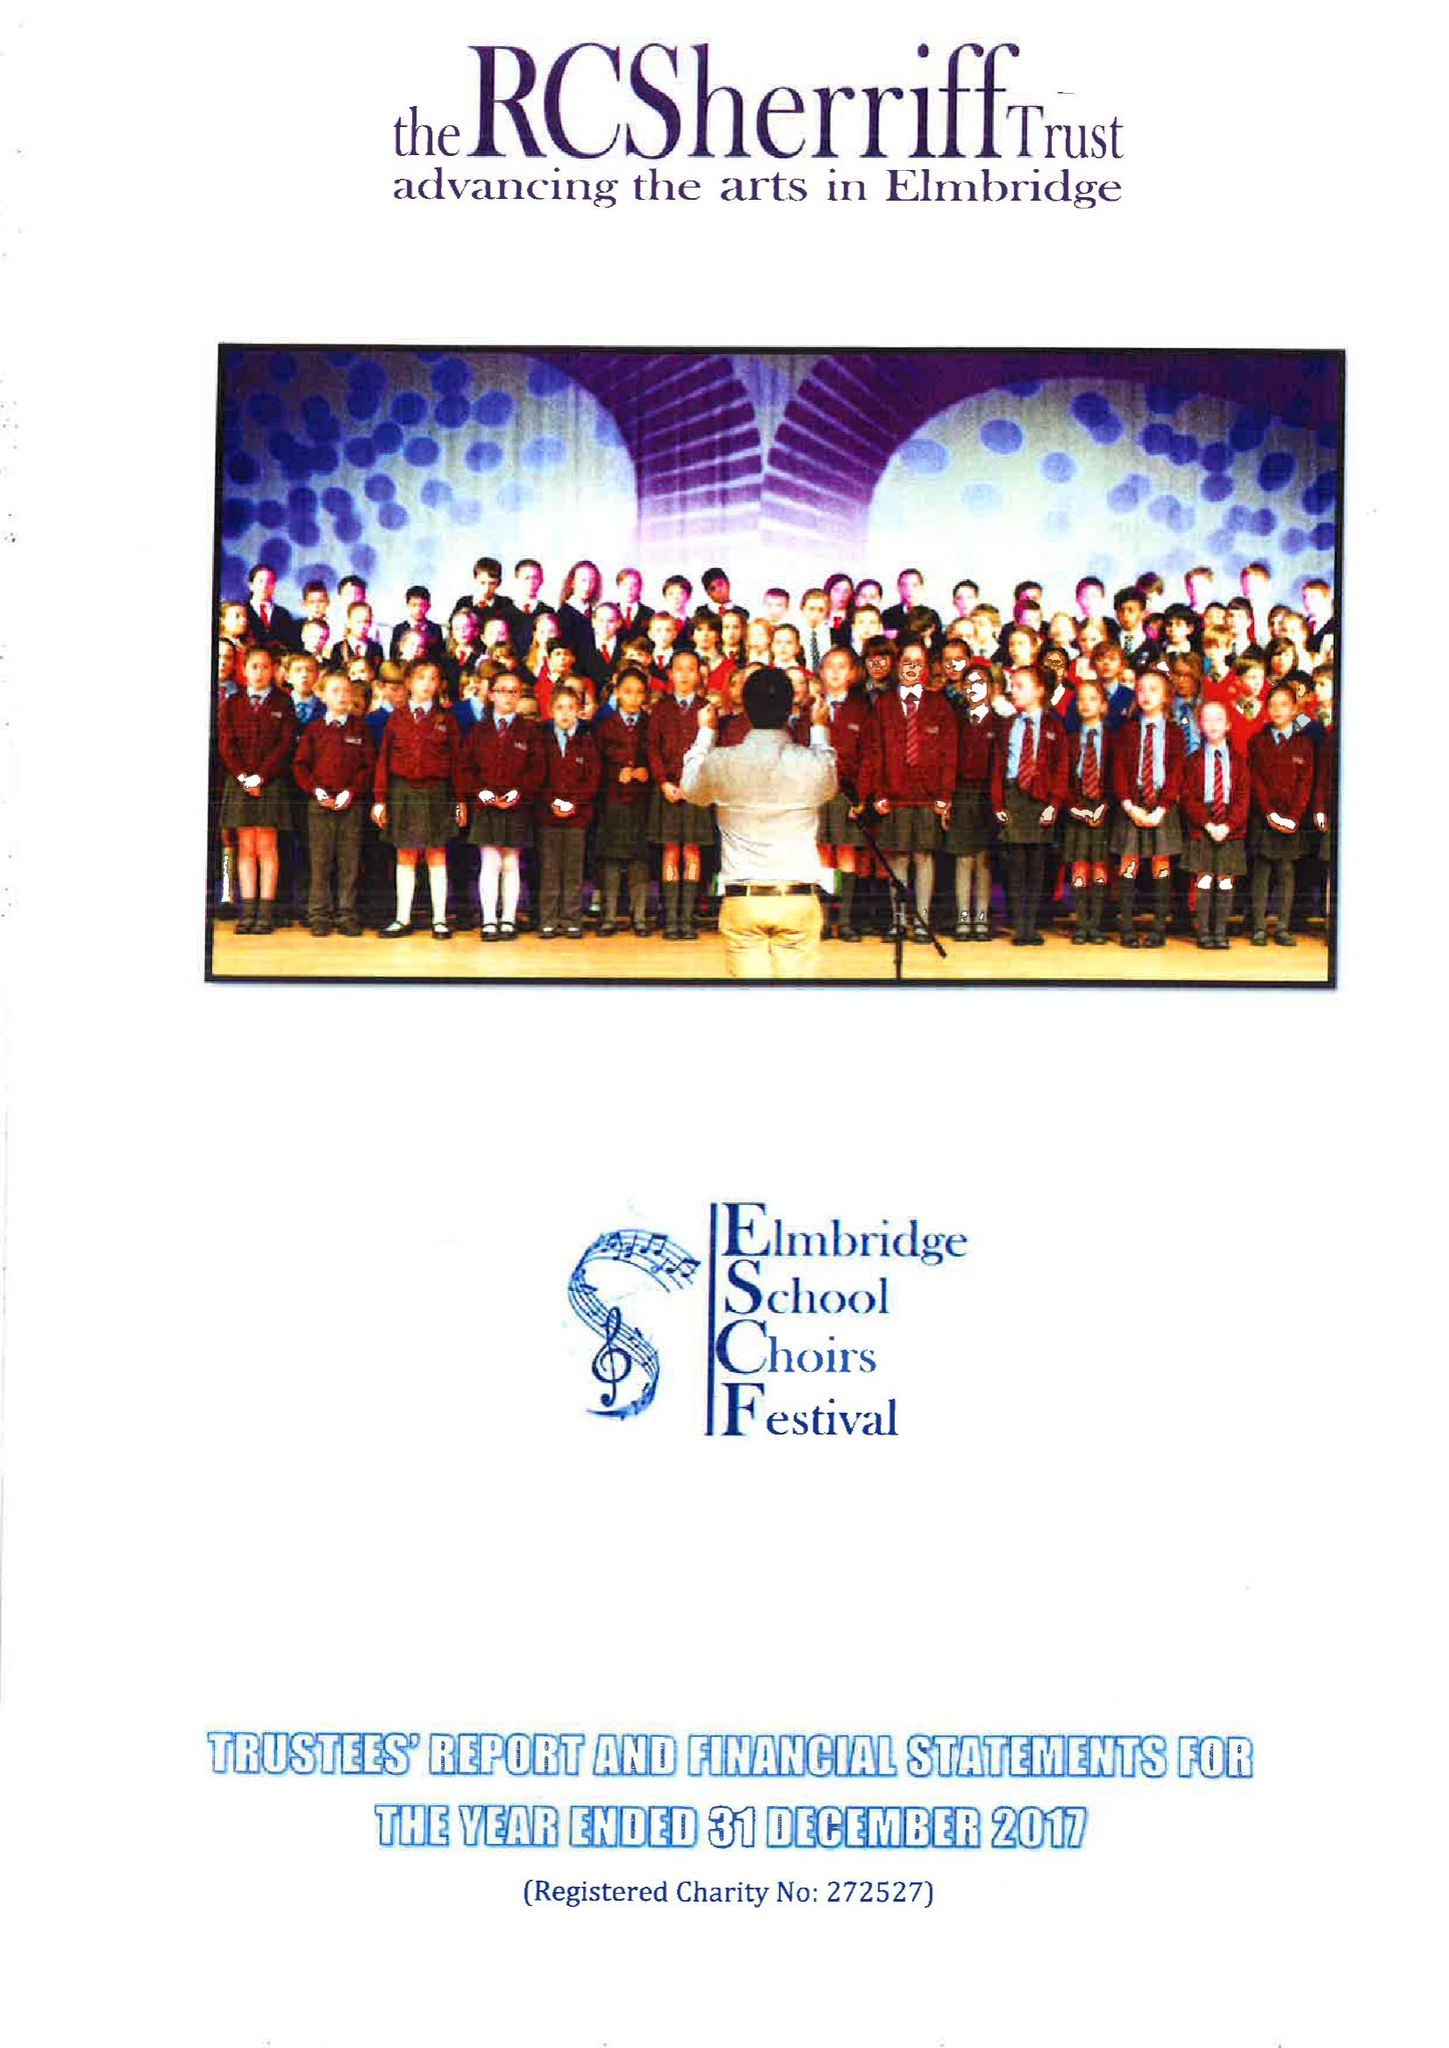What is the value for the address__street_line?
Answer the question using a single word or phrase. HIGH STREET 